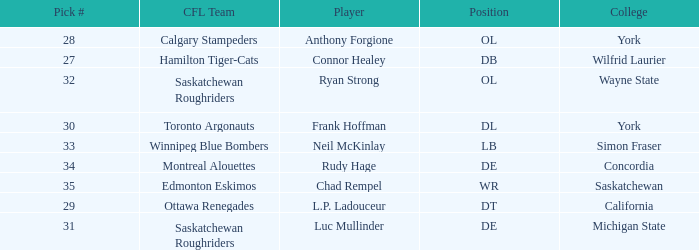What is the Pick # for the Edmonton Eskimos? 1.0. 